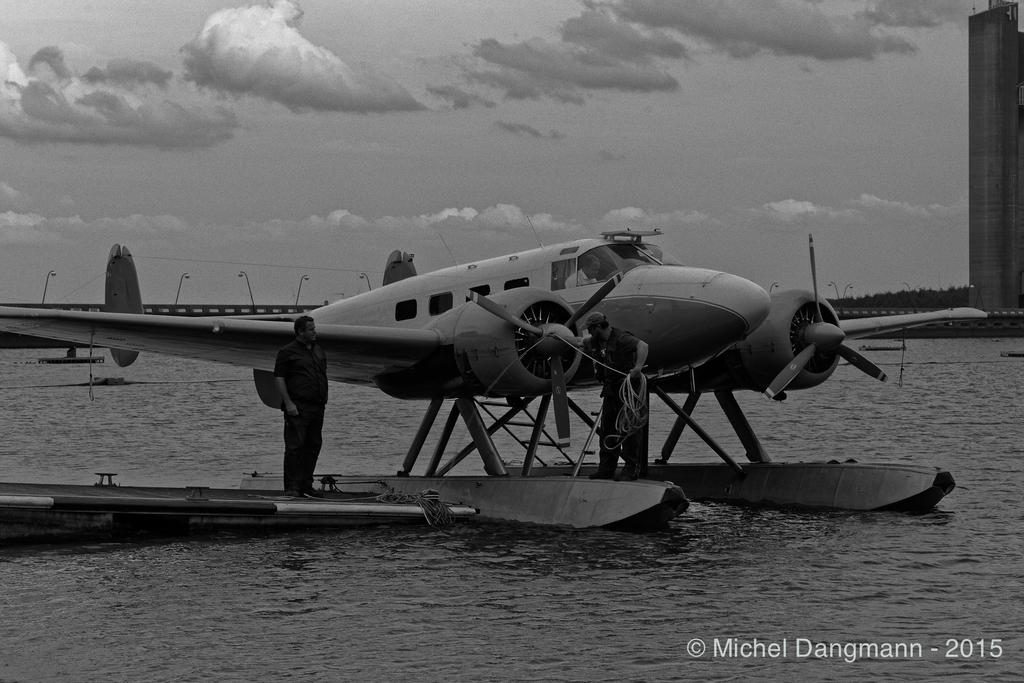<image>
Summarize the visual content of the image. a plane has landed on the water, and has a man standing beside it, taken in 2015 